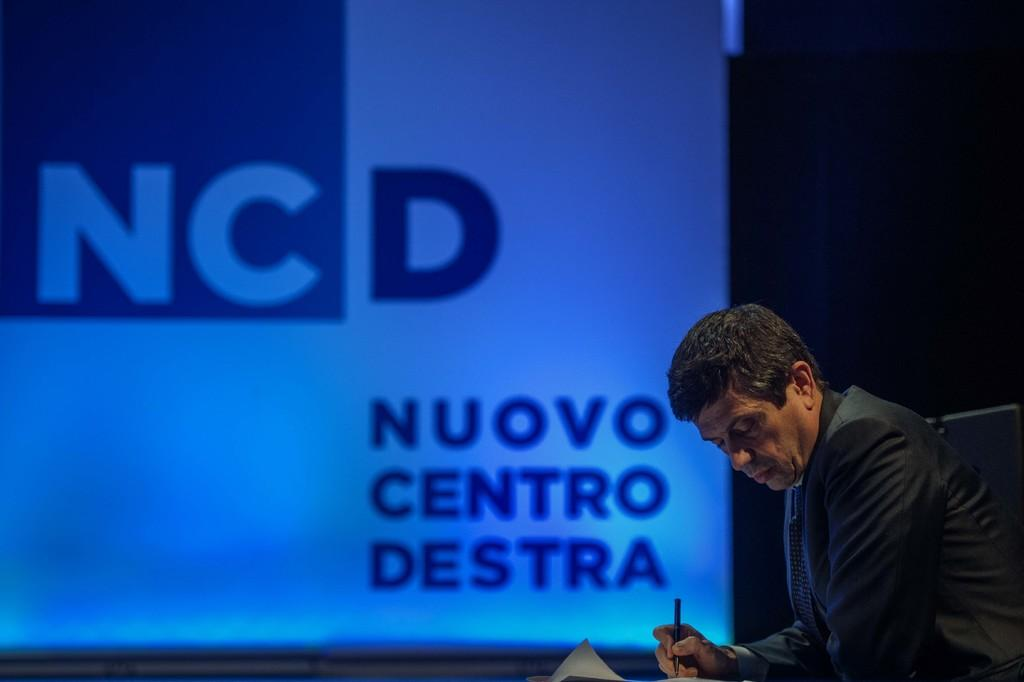What is the person in the image doing? The person is sitting in the image. What object is the person holding? The person is holding a pen. What is the person wearing? The person is wearing a black dress. What can be seen in the background of the image? There is a projector screen in the background of the image. What word is the person trying to spell with the pen in the image? There is no indication in the image that the person is trying to spell a word with the pen. 